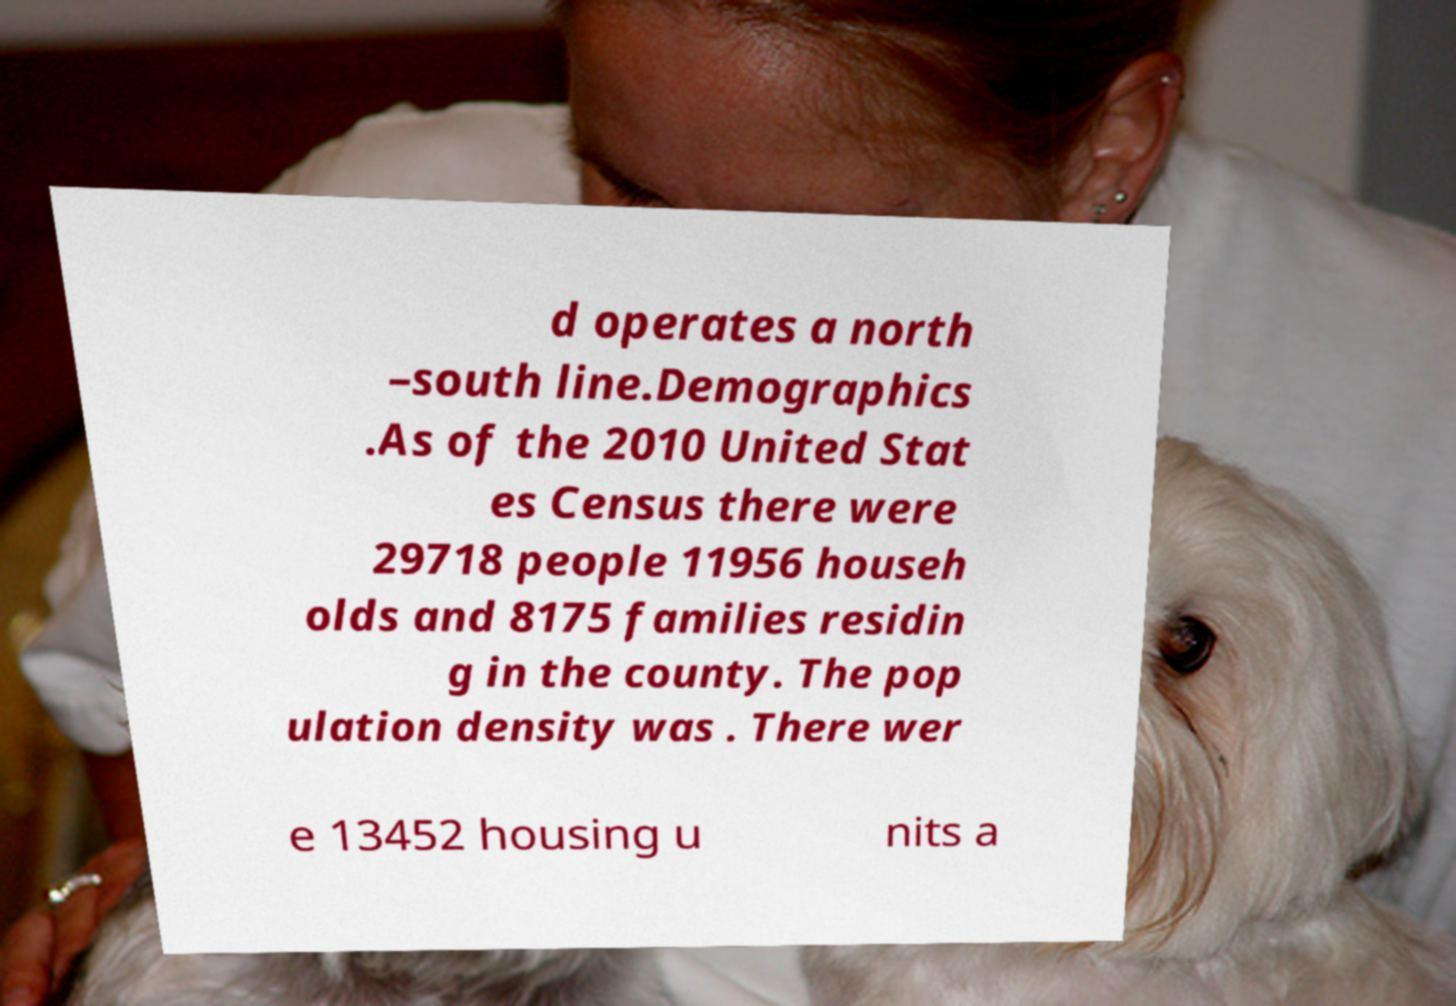For documentation purposes, I need the text within this image transcribed. Could you provide that? d operates a north –south line.Demographics .As of the 2010 United Stat es Census there were 29718 people 11956 househ olds and 8175 families residin g in the county. The pop ulation density was . There wer e 13452 housing u nits a 